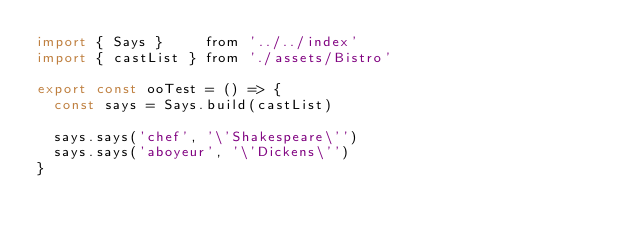<code> <loc_0><loc_0><loc_500><loc_500><_JavaScript_>import { Says }     from '../../index'
import { castList } from './assets/Bistro'

export const ooTest = () => {
  const says = Says.build(castList)

  says.says('chef', '\'Shakespeare\'')
  says.says('aboyeur', '\'Dickens\'')
}
</code> 